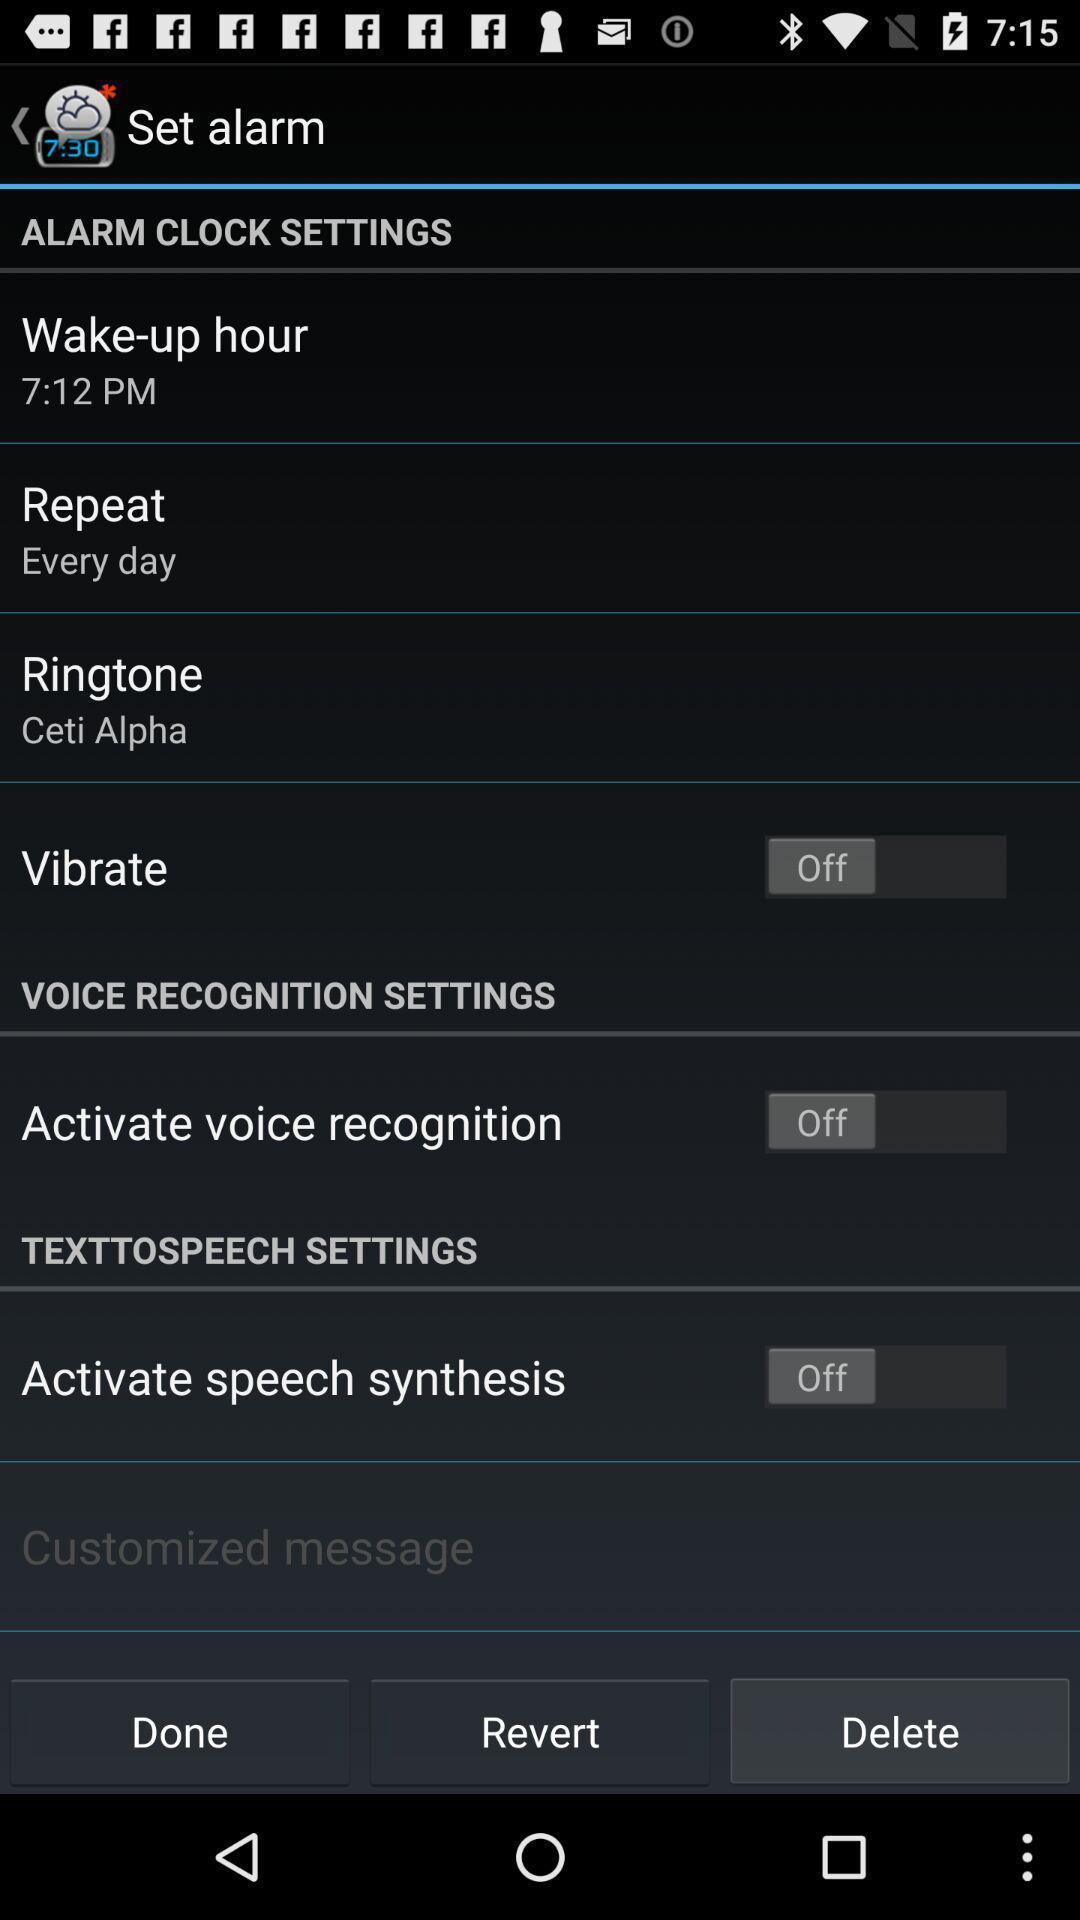Give me a narrative description of this picture. Screen showing set alarm page with various settings. 